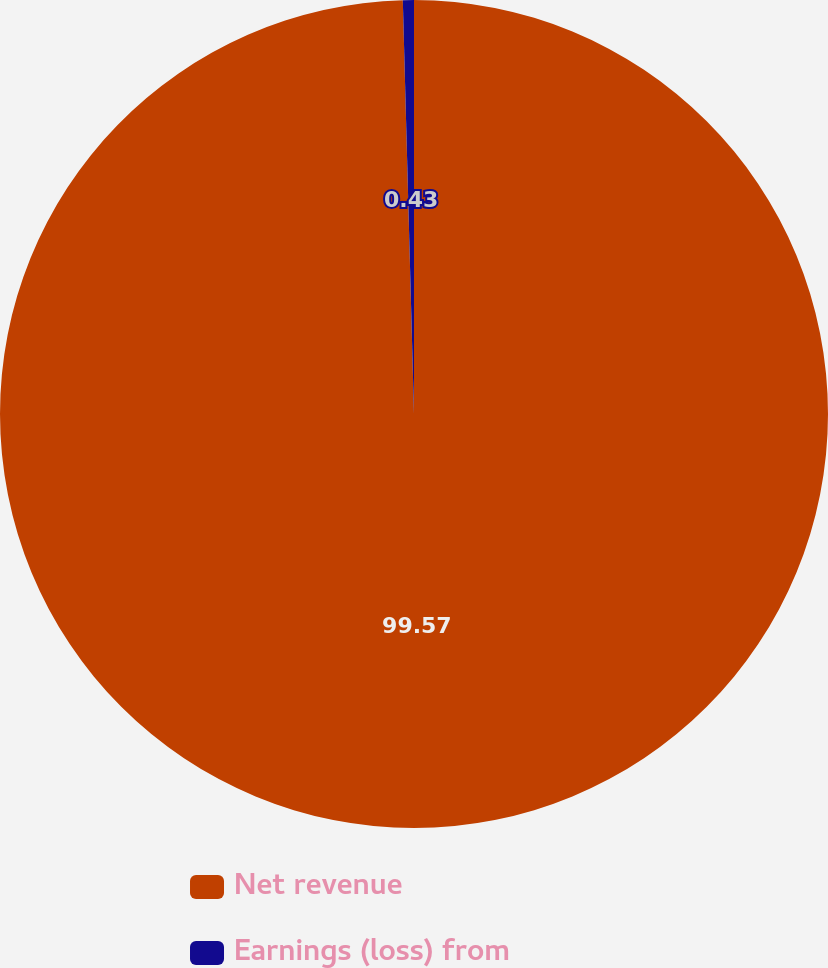Convert chart to OTSL. <chart><loc_0><loc_0><loc_500><loc_500><pie_chart><fcel>Net revenue<fcel>Earnings (loss) from<nl><fcel>99.57%<fcel>0.43%<nl></chart> 